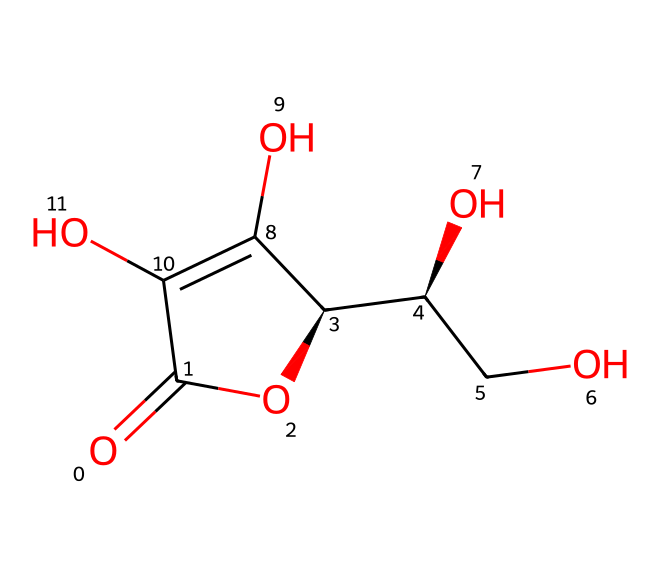What is the molecular formula of ascorbic acid? To determine the molecular formula, we analyze the SMILES representation and count the number of each type of atom present. The representation shows carbons (C), oxygens (O), and hydrogens (H). Counting them gives us C6, H8, and O6.
Answer: C6H8O6 How many hydroxyl groups are present in ascorbic acid? A hydroxyl group contains an -OH functional group. In the SMILES representation, we can identify two instances of -OH groups explicitly, indicating their presence. Counting these, we conclude there are 2 hydroxyl groups.
Answer: 2 What type of chemical structure specifically characterizes ascorbic acid? Ascorbic acid has a specific feature of being a lactone (cyclic ester). The presence of a ring structure formed from -OH and carbonyl groups indicates this. Therefore, the lactone classification applies.
Answer: lactone What is the total number of rings in the structure of ascorbic acid? Analyzing the SMILES structure reveals one cyclic part, which represents a single cyclic structure involving the carbon and oxygen atoms forming a ring. Thus, there is 1 ring.
Answer: 1 How many chiral centers does ascorbic acid have? Chiral centers are typically identified where a carbon atom is attached to four different substituents. In the SMILES notation, carbon atoms are marked where they show variations in their attached groups. By inspecting, there are 2 such chiral centers present in ascorbic acid.
Answer: 2 What is the primary role of ascorbic acid in the body? Ascorbic acid is widely recognized for its function as an antioxidant. This role helps protect cells from oxidative stress and derived damage. Therefore, the main function can be summarized as an antioxidant.
Answer: antioxidant 